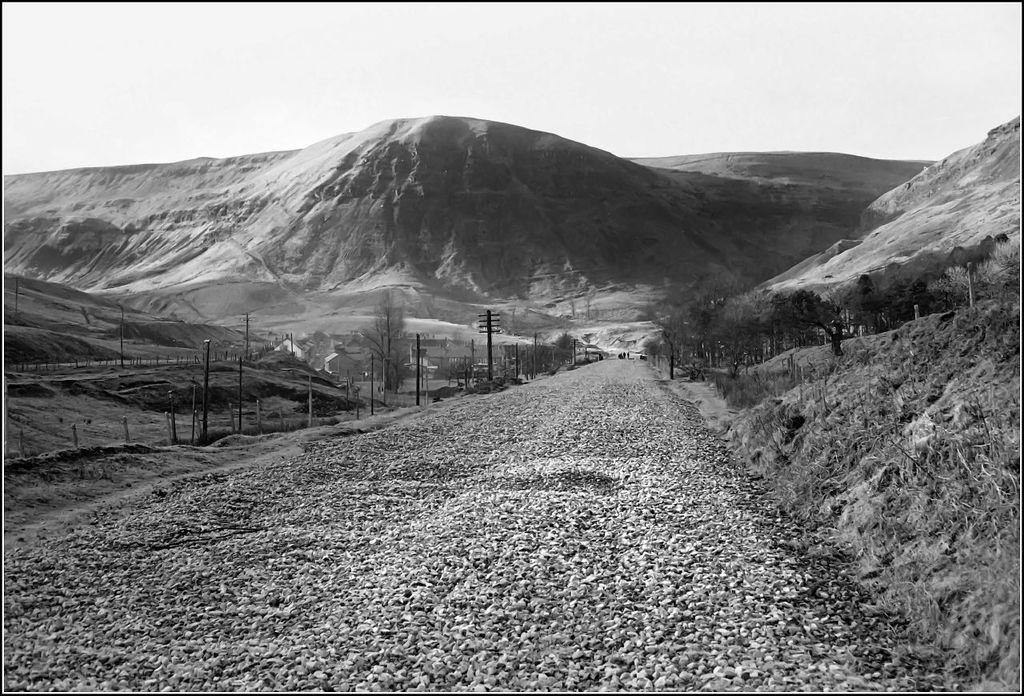Could you give a brief overview of what you see in this image? This image consists of a road. At the bottom, there are small stones. On the left and right, there are small plants and grass. In the background, there are mountains. At the top, there is sky. And we can see the poles beside the road. 